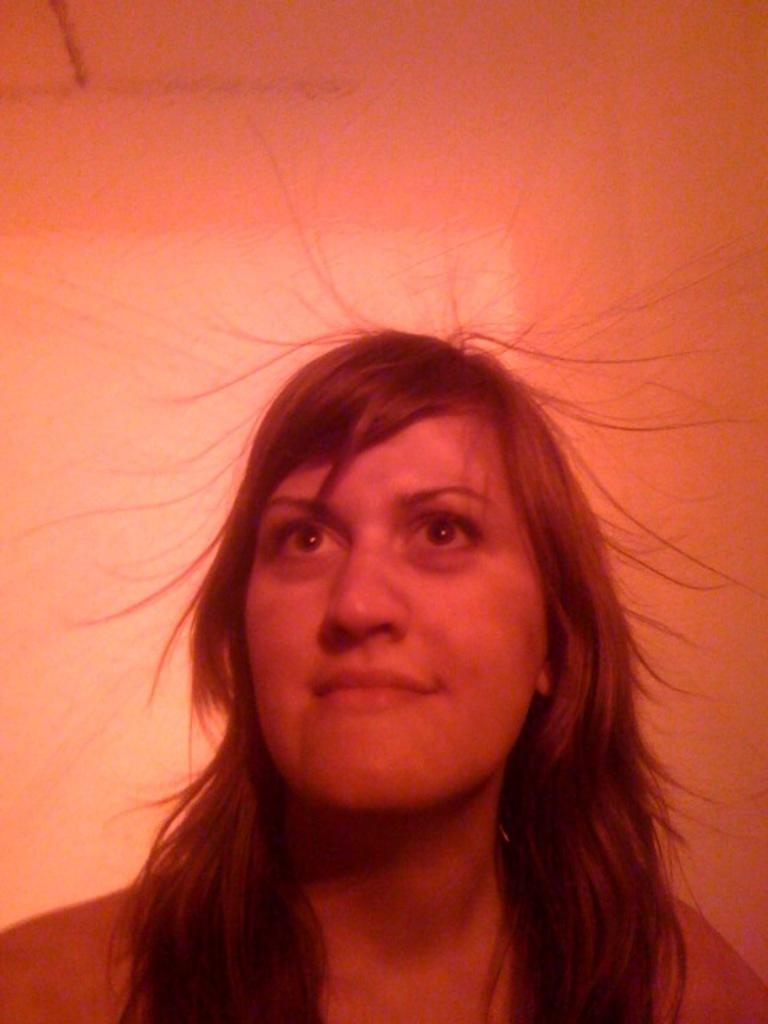Who is present in the image? There is a woman in the image. What expression does the woman have? The woman is smiling. Can you describe the background of the image? The background of the image is blurry. What type of railway treatment is the woman undergoing in the image? There is no railway or treatment present in the image; it features a woman smiling with a blurry background. 